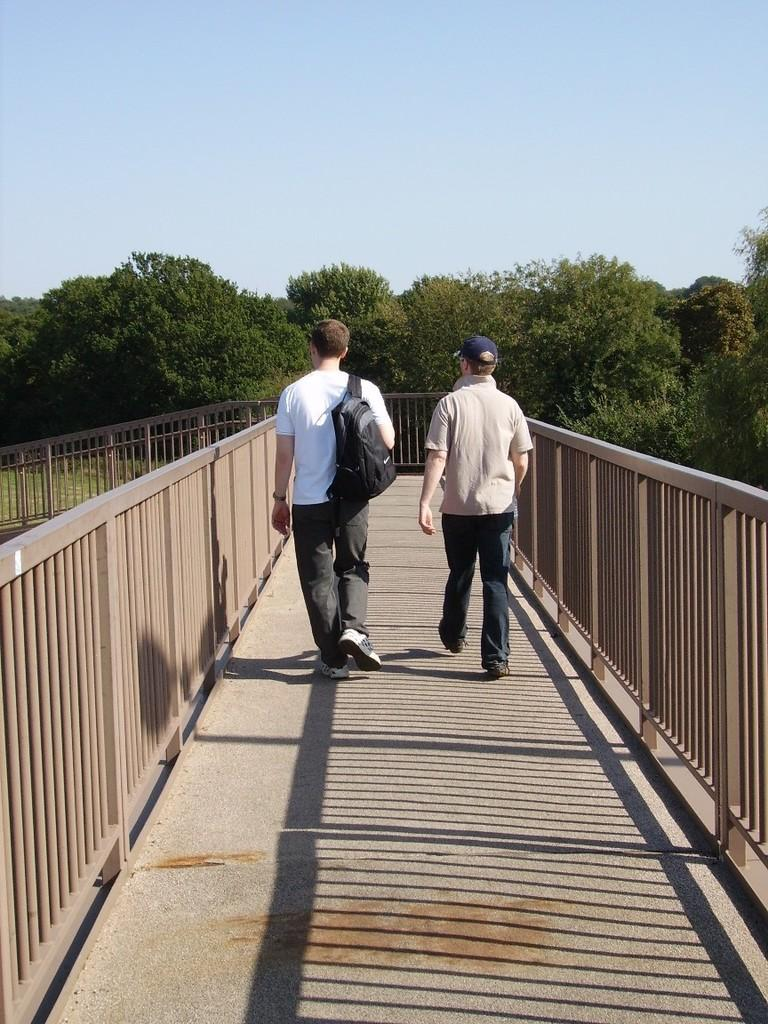How many people are in the image? There are two people in the image. What are the two people doing in the image? The two people are walking on a bridge. What can be seen in the background of the image? There are trees and the sky visible in the background of the image. What is the father figure in the image? There is no mention of a father figure in the image. 